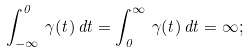<formula> <loc_0><loc_0><loc_500><loc_500>\int _ { - \infty } ^ { 0 } \, \gamma ( t ) \, d t = \int _ { 0 } ^ { \infty } \, \gamma ( t ) \, d t = \infty ;</formula> 